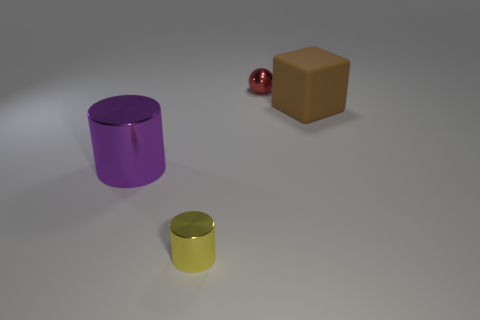Add 4 red metallic balls. How many objects exist? 8 Subtract all balls. How many objects are left? 3 Subtract 0 brown balls. How many objects are left? 4 Subtract all purple shiny cylinders. Subtract all purple metal things. How many objects are left? 2 Add 4 large brown rubber blocks. How many large brown rubber blocks are left? 5 Add 3 tiny red spheres. How many tiny red spheres exist? 4 